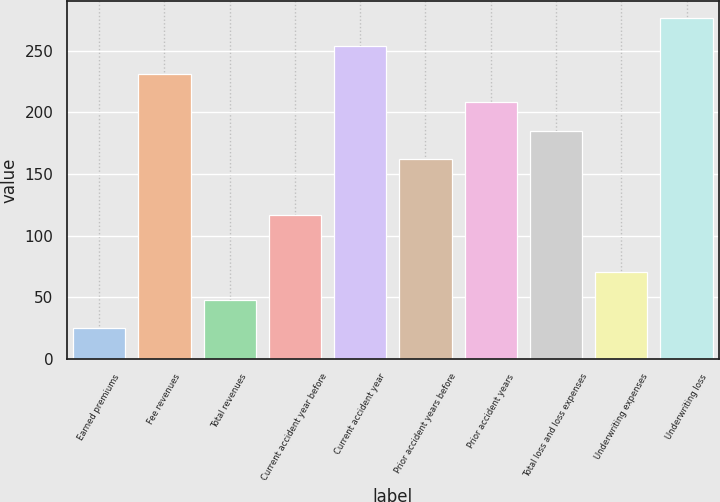Convert chart. <chart><loc_0><loc_0><loc_500><loc_500><bar_chart><fcel>Earned premiums<fcel>Fee revenues<fcel>Total revenues<fcel>Current accident year before<fcel>Current accident year<fcel>Prior accident years before<fcel>Prior accident years<fcel>Total loss and loss expenses<fcel>Underwriting expenses<fcel>Underwriting loss<nl><fcel>24.9<fcel>231<fcel>47.8<fcel>116.5<fcel>253.9<fcel>162.3<fcel>208.1<fcel>185.2<fcel>70.7<fcel>276.8<nl></chart> 